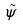<formula> <loc_0><loc_0><loc_500><loc_500>\tilde { \psi }</formula> 